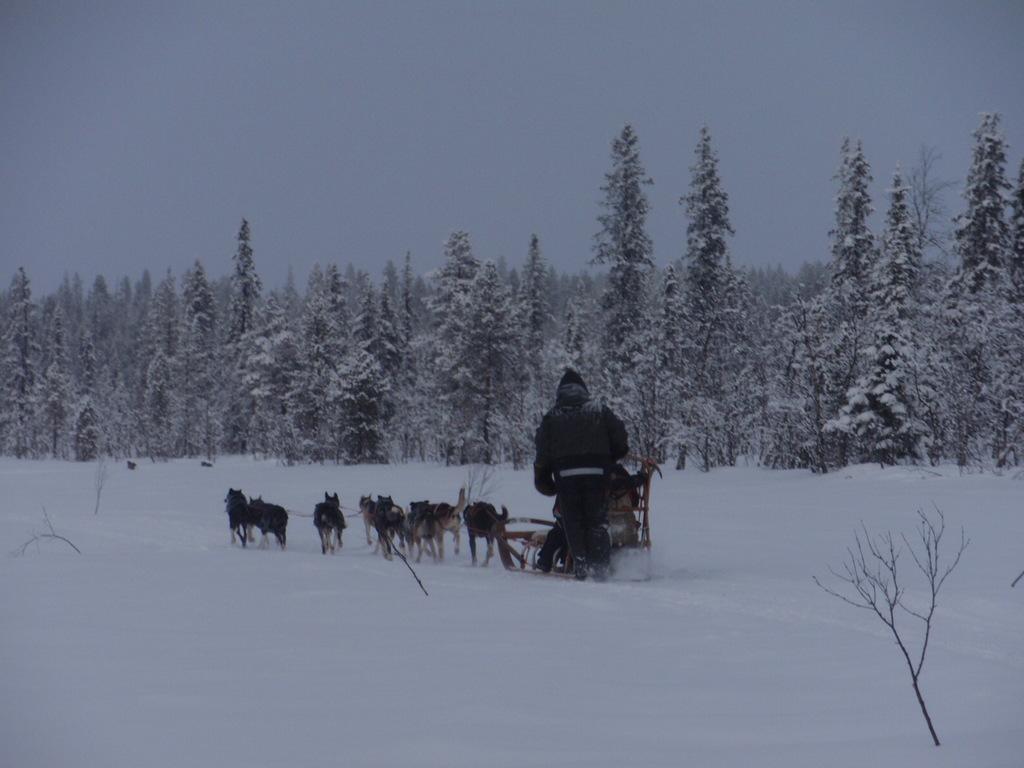In one or two sentences, can you explain what this image depicts? In this picture we can observe some dogs pulling the sledge. There is a person on the sledge. The dogs were pulling the sledge on the snow. In the background there are some trees which were covered with snow. There is a sky. 